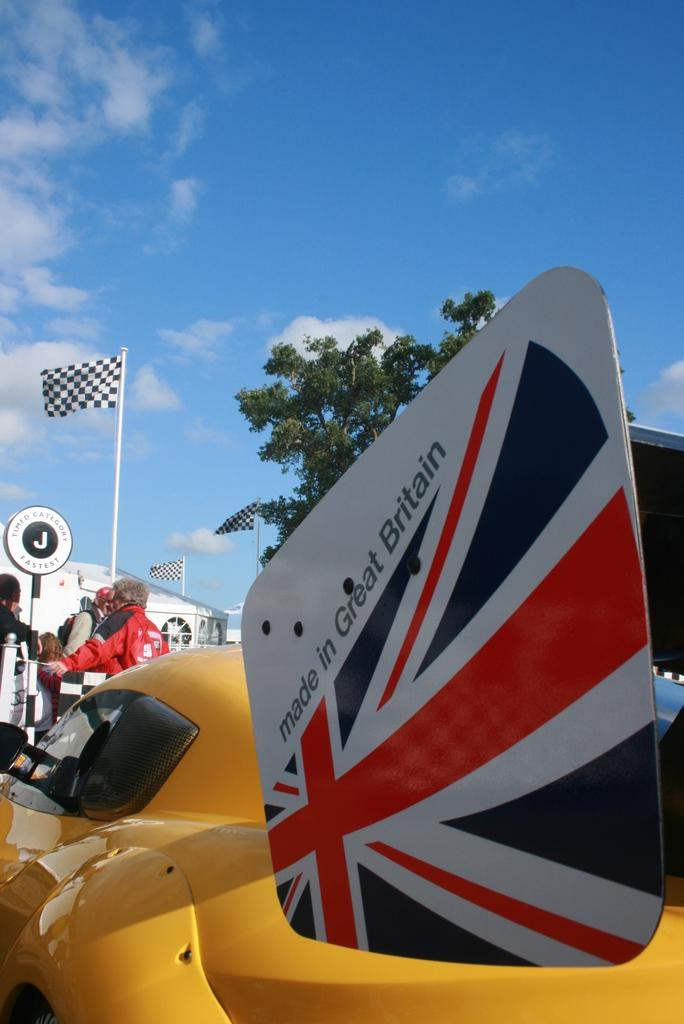<image>
Summarize the visual content of the image. A yellow race car made in Great Britain and a man with a red jacket in front of the car talking to other people. 